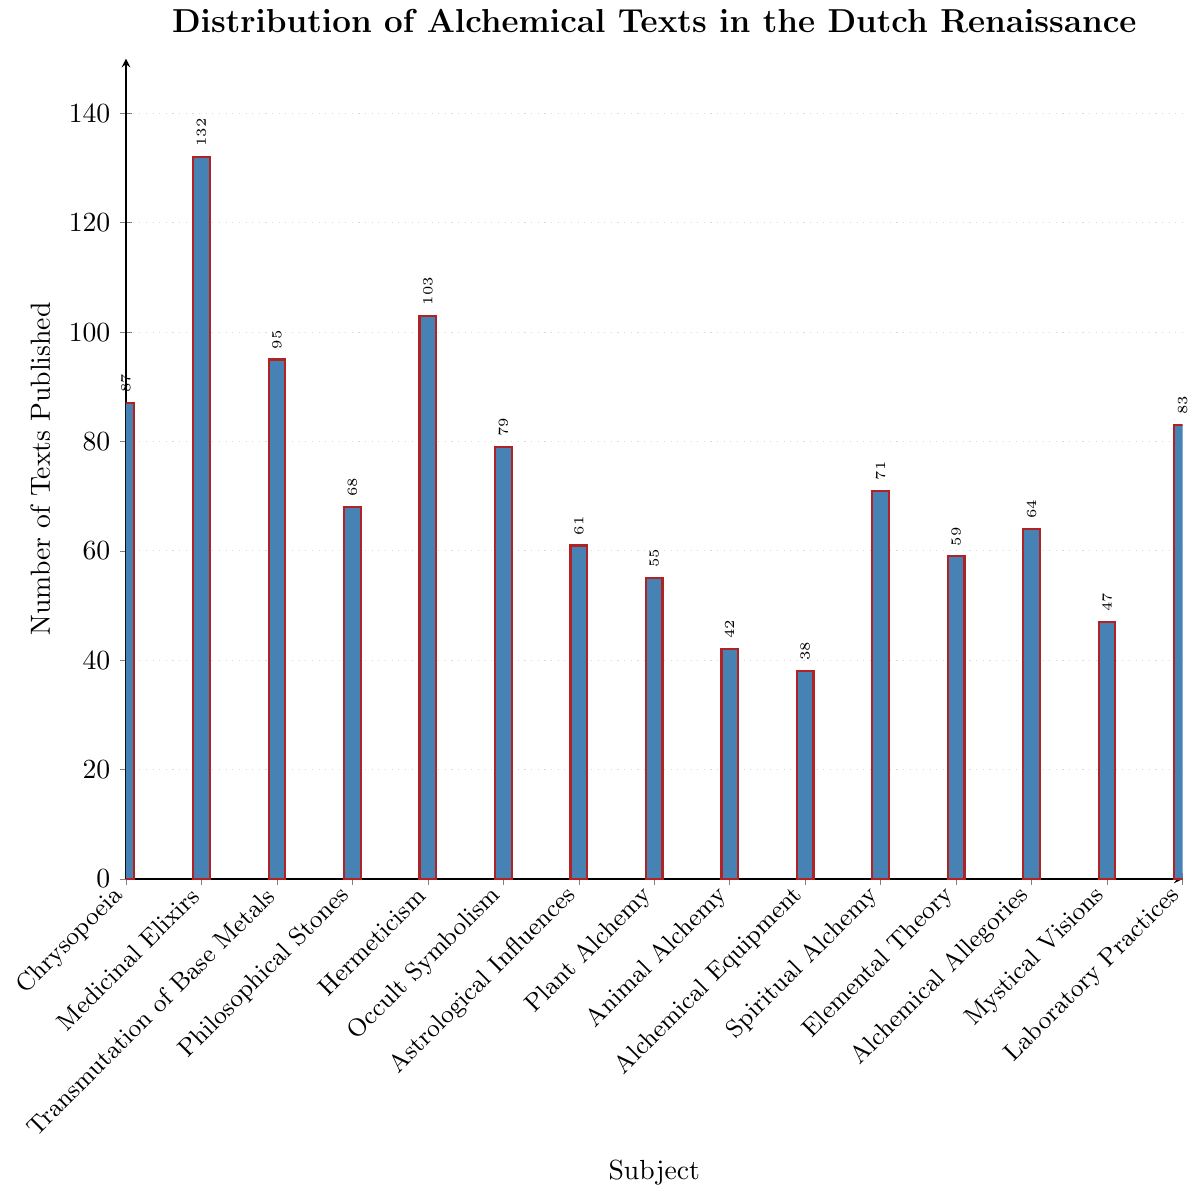Which subject has the highest number of texts published? To find the subject with the highest number of texts, look at the heights of the bars and find the tallest one. The bar for "Medicinal Elixirs" is the tallest at 132.
Answer: Medicinal Elixirs How many more texts are published on Hermeticism compared to Spiritual Alchemy? To calculate the difference between Hermeticism and Spiritual Alchemy, find the values for each subject and subtract the smaller from the larger: Hermeticism (103) - Spiritual Alchemy (71) = 32.
Answer: 32 What is the average number of texts published across all subjects? Calculate the average by summing all the texts and then dividing by the number of subjects: (87 + 132 + 95 + 68 + 103 + 79 + 61 + 55 + 42 + 38 + 71 + 59 + 64 + 47 + 83) / 15 = 1084 / 15 ≈ 72.27.
Answer: ~72.27 Which two subjects have the closest numbers of texts published? Look for bars with similar heights. "Spiritual Alchemy" (71) and "Philosophical Stones" (68) are the closest, with a difference of only 3.
Answer: Spiritual Alchemy and Philosophical Stones What is the median number of texts published? Order the numbers and find the middle value: 38, 42, 47, 55, 59, 61, 64, 68, 71, 79, 83, 87, 95, 103, 132. The median is the 8th value, which is 68.
Answer: 68 What is the combined total of texts published for subjects related to metal work (Chrysopoeia and Transmutation of Base Metals)? Add the numbers for Chrysopoeia and Transmutation of Base Metals: 87 + 95 = 182.
Answer: 182 Which subjects have fewer than 50 texts published? Identify bars representing fewer than 50 texts. The subjects are Animal Alchemy (42) and Alchemical Equipment (38).
Answer: Animal Alchemy and Alchemical Equipment How many more texts were published on Medicinal Elixirs compared to the least published subject? Find the difference between Medicinal Elixirs (132) and the least published subject, Alchemical Equipment (38): 132 - 38 = 94.
Answer: 94 What fraction of the total texts does Hermeticism represent? Calculate Hermeticism's fraction of the total: Hermeticism (103) / Total (1084) ≈ 0.095 (or 9.5%).
Answer: ~9.5% What subjects have more than 100 texts published? Identify bars representing more than 100 texts. The subjects are Medicinal Elixirs (132) and Hermeticism (103).
Answer: Medicinal Elixirs and Hermeticism 